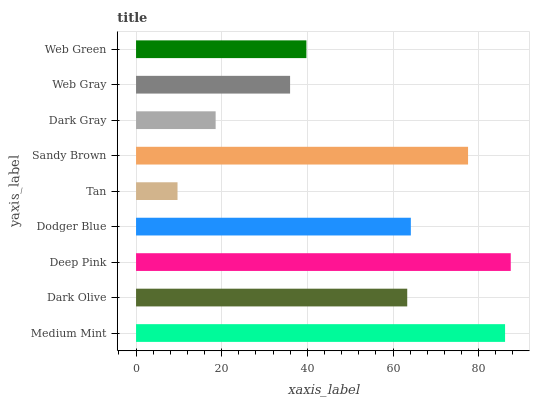Is Tan the minimum?
Answer yes or no. Yes. Is Deep Pink the maximum?
Answer yes or no. Yes. Is Dark Olive the minimum?
Answer yes or no. No. Is Dark Olive the maximum?
Answer yes or no. No. Is Medium Mint greater than Dark Olive?
Answer yes or no. Yes. Is Dark Olive less than Medium Mint?
Answer yes or no. Yes. Is Dark Olive greater than Medium Mint?
Answer yes or no. No. Is Medium Mint less than Dark Olive?
Answer yes or no. No. Is Dark Olive the high median?
Answer yes or no. Yes. Is Dark Olive the low median?
Answer yes or no. Yes. Is Dodger Blue the high median?
Answer yes or no. No. Is Medium Mint the low median?
Answer yes or no. No. 